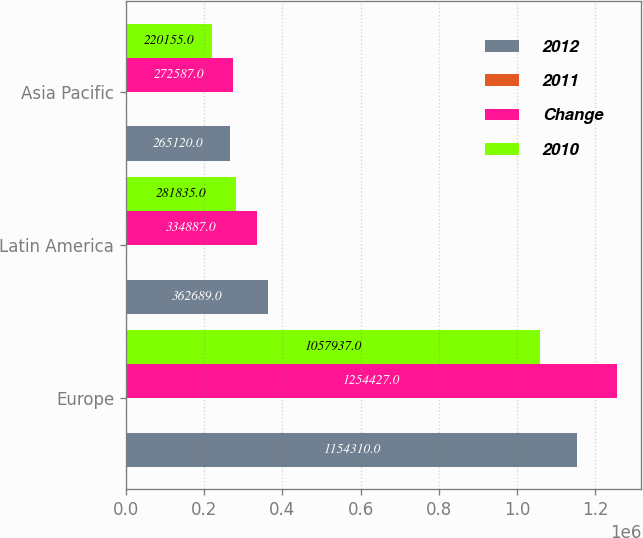Convert chart. <chart><loc_0><loc_0><loc_500><loc_500><stacked_bar_chart><ecel><fcel>Europe<fcel>Latin America<fcel>Asia Pacific<nl><fcel>2012<fcel>1.15431e+06<fcel>362689<fcel>265120<nl><fcel>2011<fcel>8<fcel>8<fcel>3<nl><fcel>Change<fcel>1.25443e+06<fcel>334887<fcel>272587<nl><fcel>2010<fcel>1.05794e+06<fcel>281835<fcel>220155<nl></chart> 